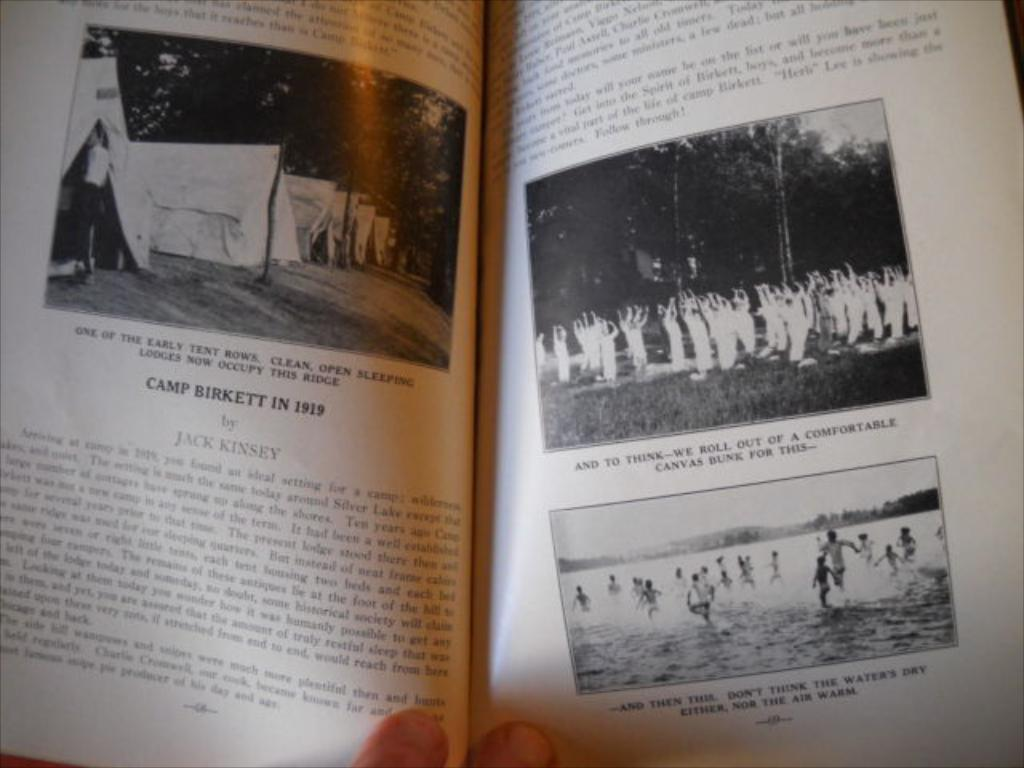<image>
Summarize the visual content of the image. A story about Camp Birkett in 1919 by Jack Kinsey. 